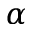Convert formula to latex. <formula><loc_0><loc_0><loc_500><loc_500>\alpha</formula> 